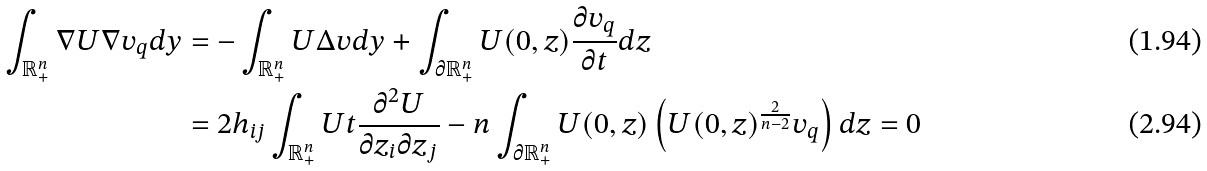Convert formula to latex. <formula><loc_0><loc_0><loc_500><loc_500>\int _ { \mathbb { R } _ { + } ^ { n } } \nabla U \nabla v _ { q } d y & = - \int _ { \mathbb { R } _ { + } ^ { n } } U \Delta v d y + \int _ { \partial \mathbb { R } _ { + } ^ { n } } U ( 0 , z ) \frac { \partial v _ { q } } { \partial t } d z \\ & = 2 h _ { i j } \int _ { \mathbb { R } _ { + } ^ { n } } U t \frac { \partial ^ { 2 } U } { \partial z _ { i } \partial z _ { j } } - n \int _ { \partial \mathbb { R } _ { + } ^ { n } } U ( 0 , z ) \left ( U ( 0 , z ) ^ { \frac { 2 } { n - 2 } } v _ { q } \right ) d z = 0</formula> 